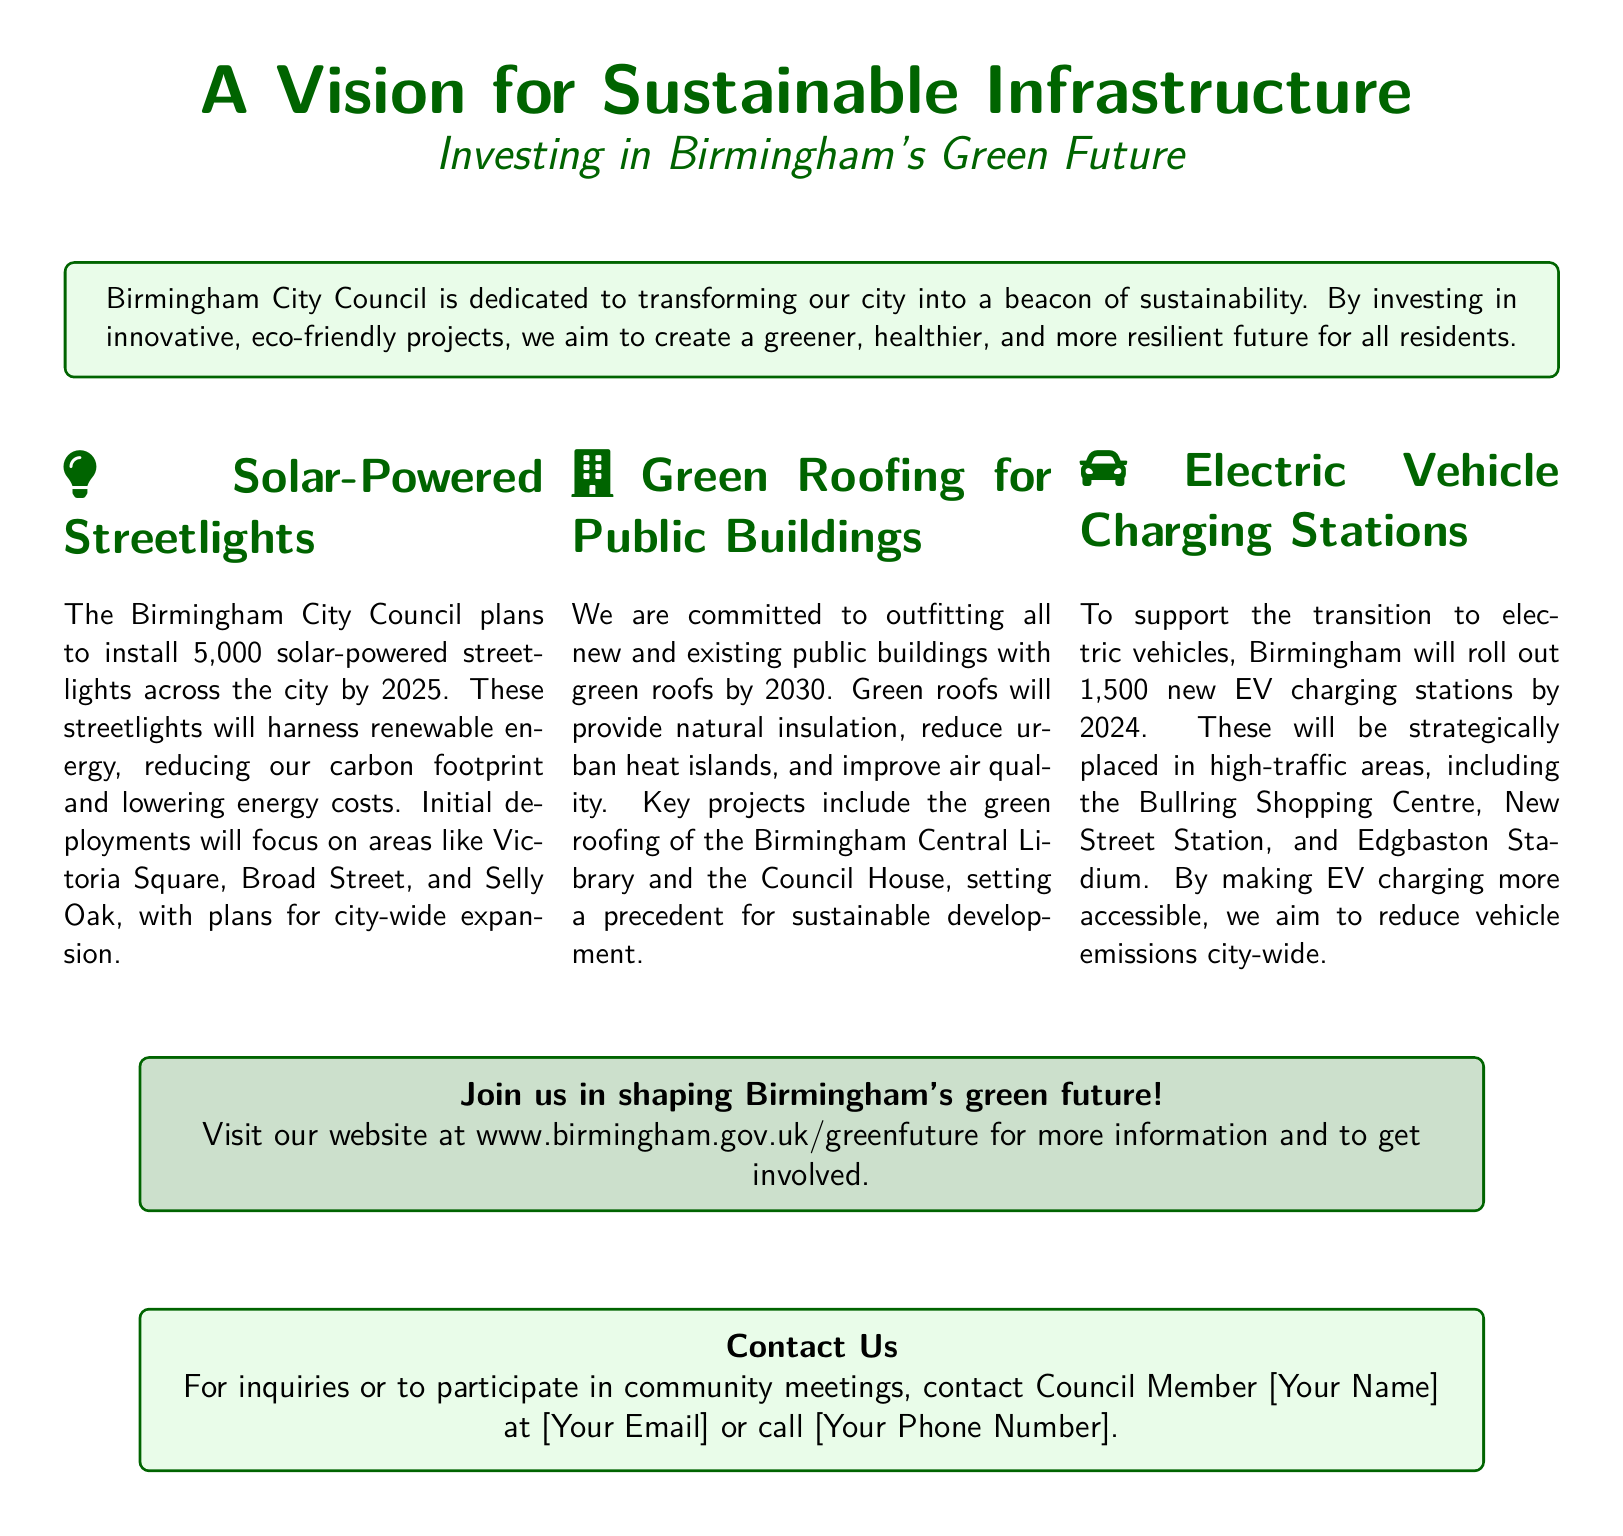What is the total number of solar-powered streetlights planned? The total number of solar-powered streetlights is mentioned as 5,000, which will be installed by 2025.
Answer: 5,000 What year is the deadline for installing electric vehicle charging stations? The document states that 1,500 new EV charging stations will be rolled out by 2024.
Answer: 2024 Which two public buildings will have green roofs? The key projects mentioned for green roofing are the Birmingham Central Library and the Council House.
Answer: Birmingham Central Library and the Council House What is one benefit of green roofs mentioned in the document? The benefits of green roofs include providing natural insulation, reducing urban heat islands, and improving air quality; a specific answer could be one of these benefits.
Answer: Natural insulation In which areas will the initial solar-powered streetlights be deployed? The initial deployments of solar-powered streetlights will focus on areas like Victoria Square, Broad Street, and Selly Oak.
Answer: Victoria Square, Broad Street, and Selly Oak What is the website mentioned for more information? The document provides a specific URL for more information about Birmingham's green future initiatives.
Answer: www.birmingham.gov.uk/greenfuture How many electric vehicle charging stations will be placed in high-traffic areas? The document states that Birmingham will roll out 1,500 EV charging stations strategically placed in high-traffic areas.
Answer: 1,500 What is the aim of Birmingham City Council by investing in eco-friendly projects? The aim of investing in these projects is to transform Birmingham into a greener, healthier, and more resilient city.
Answer: A greener, healthier, and more resilient city What color is the box that discusses solar-powered streetlights? The color of the box that discusses solar-powered streetlights is light green with dark green text.
Answer: Light green 